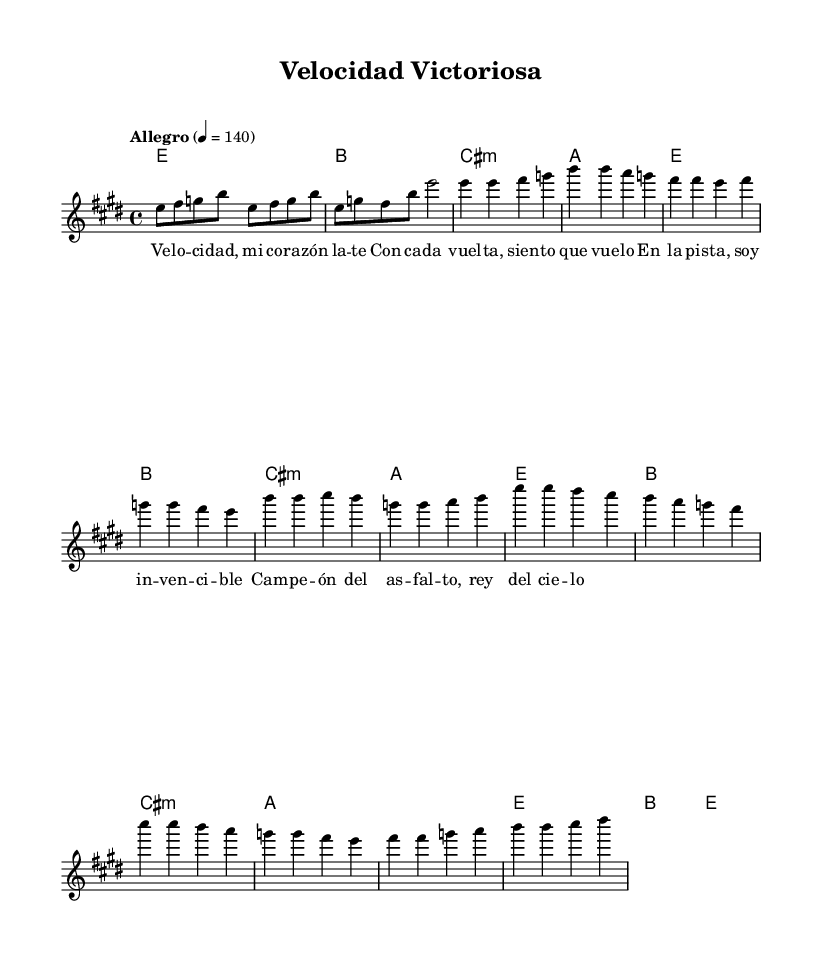What is the key signature of this music? The key signature in the music indicates the key of E major, which has four sharps (F#, C#, G#, D#). This is seen in the global settings in the LilyPond code.
Answer: E major What is the time signature? The time signature of the piece is found in the global settings. It is noted as 4/4, meaning there are four beats in a measure, and a quarter note receives one beat.
Answer: 4/4 What is the tempo marking of the piece? The tempo is indicated in the global settings, specifically stating "Allegro" at a marking of 140 beats per minute. This indicates a fast-paced feel typical of upbeat Latin rock songs.
Answer: Allegro 4 = 140 How many measures are there in the chorus? In the provided melody, the chorus section can be counted by analyzing the melody notation. There are a total of four measures present in the chorus section from the sheet music.
Answer: 4 Which chord is played in the bridge? The bridge section contains specific chord changes notated in the harmonies. The first chord in the bridge section is A major, as indicated in the chord progression listed there.
Answer: A What is the lyrical theme of the chorus? The lyrics of the chorus emphasize speed and competition, referencing 'velocidad' (speed) and feelings of invincibility on the track. Observing the lyrics gives insight into the thematic focus.
Answer: Thrill of speed What is the highest note in the melody? By reviewing the melody part from the sheet music, the highest note reached is B, which appears in the chorus section. The melodic line shows that B is the peak note.
Answer: B 